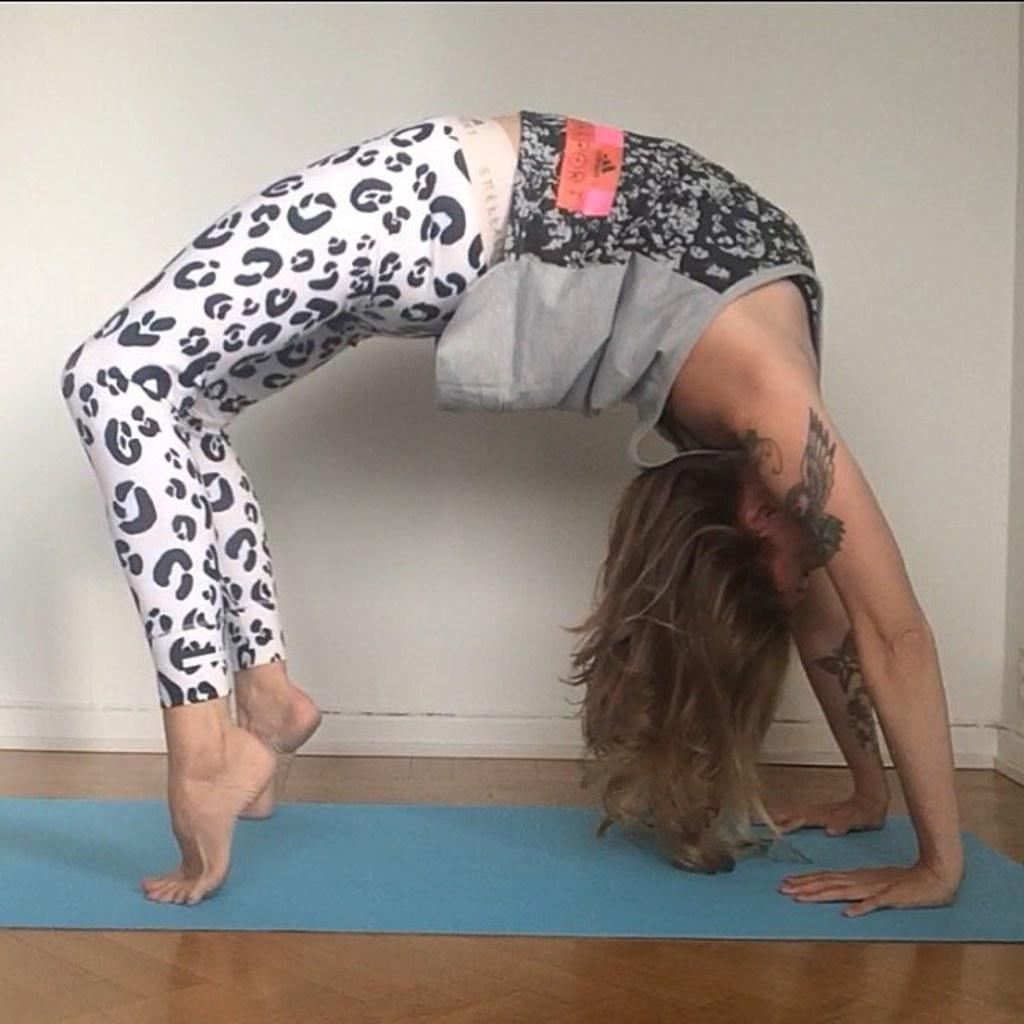Who is in the image? There is a woman in the image. What is the woman doing in the image? The woman is in a yoga posture. What is the woman using to perform the yoga posture? There is a yoga mat in the image, which the woman is using. Where is the yoga mat located? The yoga mat is on the floor. What can be seen in the background of the image? There is a wall in the background of the image. What color is the wall? The wall is white in color. How many boats are visible in the image? There are no boats present in the image. What type of farm animals can be seen in the image? There are no farm animals present in the image. 